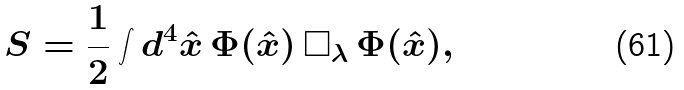<formula> <loc_0><loc_0><loc_500><loc_500>S = \frac { 1 } { 2 } \int d ^ { 4 } \hat { x } \, \Phi ( \hat { x } ) \, { \square _ { \lambda } } \, \Phi ( \hat { x } ) , \</formula> 